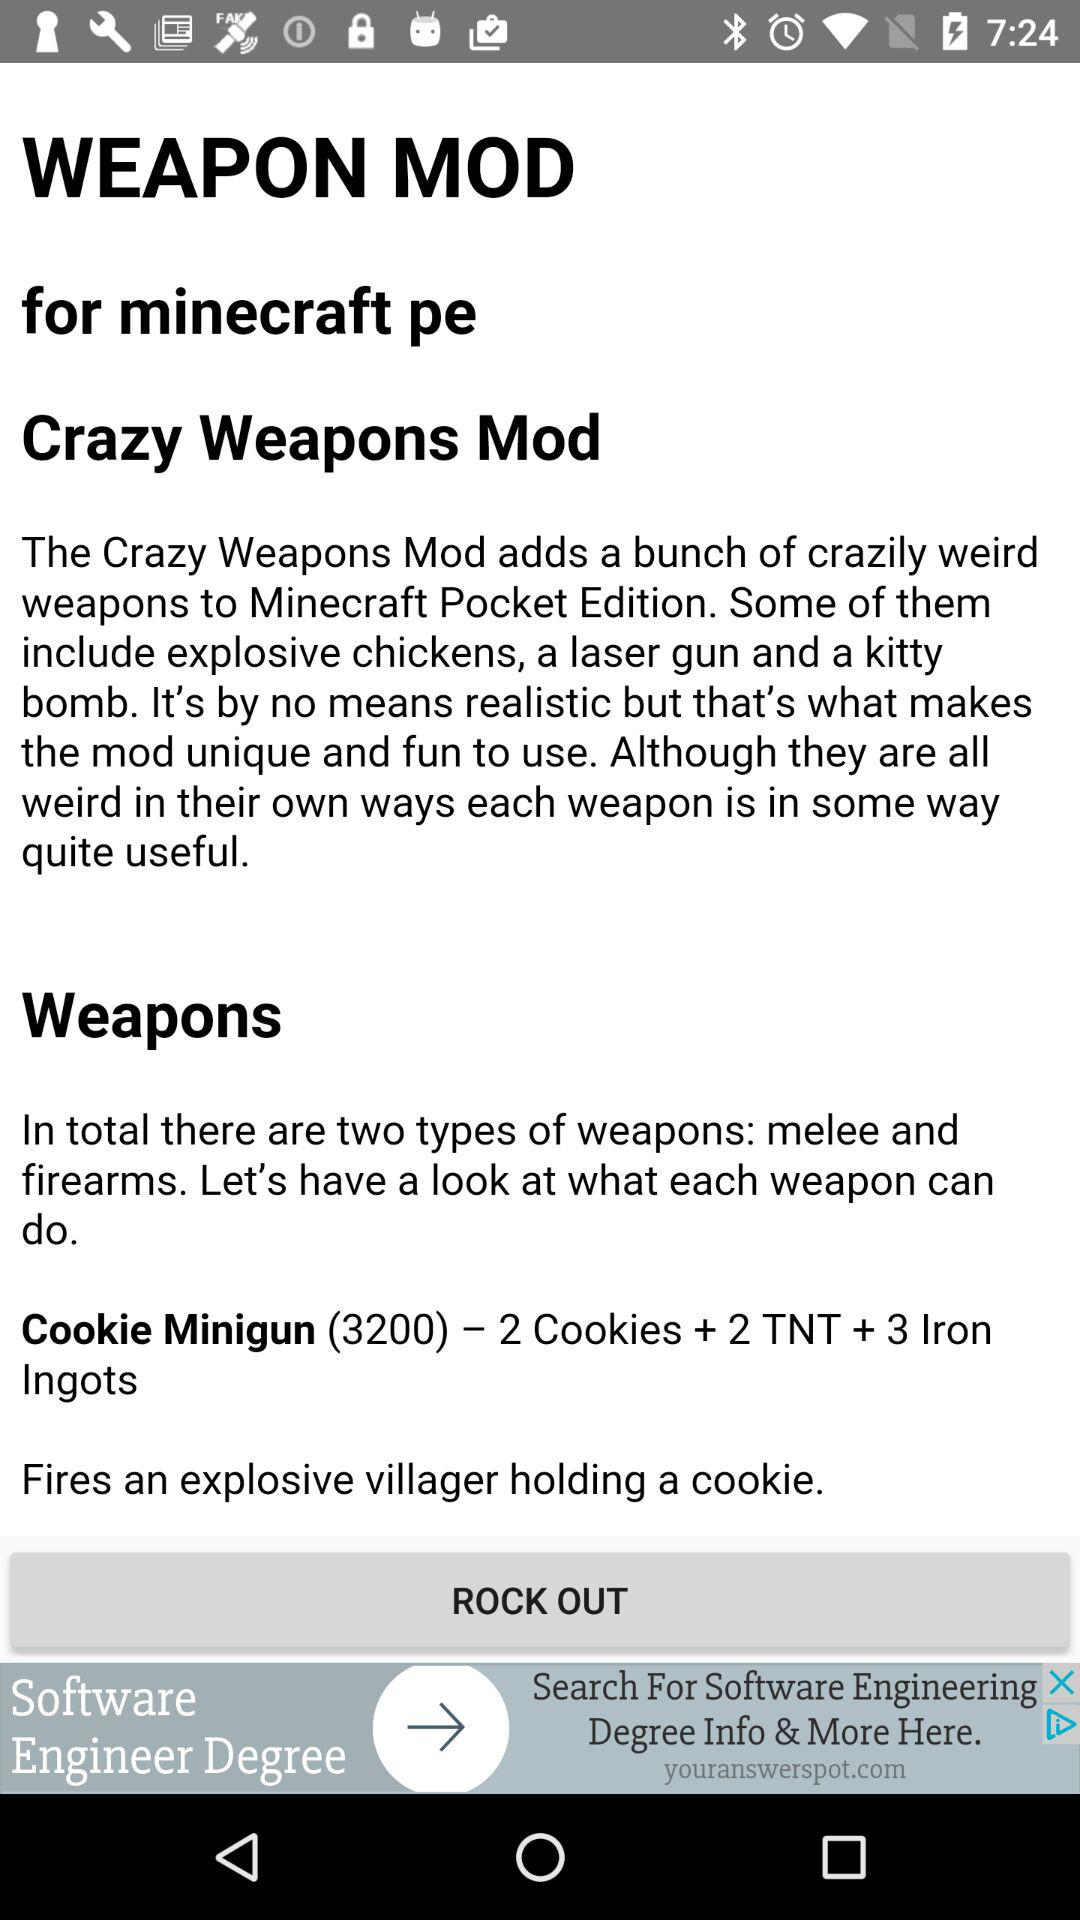How many iron ingots are required to make a cookie minigun?
Answer the question using a single word or phrase. 3 